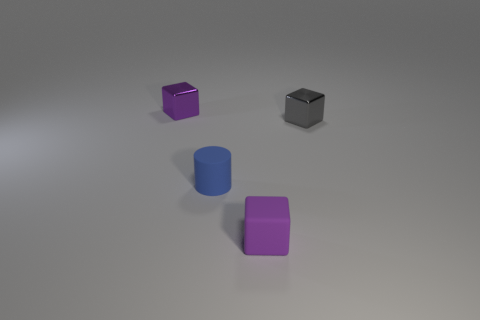There is a small gray shiny thing; what shape is it?
Your answer should be very brief. Cube. There is a tiny cylinder; how many small purple objects are to the right of it?
Ensure brevity in your answer.  1. How many purple cubes have the same material as the small gray cube?
Provide a short and direct response. 1. Is the material of the purple cube that is on the left side of the tiny purple matte thing the same as the tiny cylinder?
Your response must be concise. No. Are there any purple matte blocks?
Your answer should be compact. Yes. What is the size of the object that is right of the tiny blue object and to the left of the gray metallic object?
Your response must be concise. Small. Is the number of blue matte cylinders on the right side of the small purple rubber object greater than the number of tiny blocks that are right of the gray block?
Your response must be concise. No. The object that is the same color as the small rubber block is what size?
Your response must be concise. Small. The matte cube has what color?
Ensure brevity in your answer.  Purple. There is a thing that is in front of the gray block and on the right side of the cylinder; what color is it?
Provide a short and direct response. Purple. 